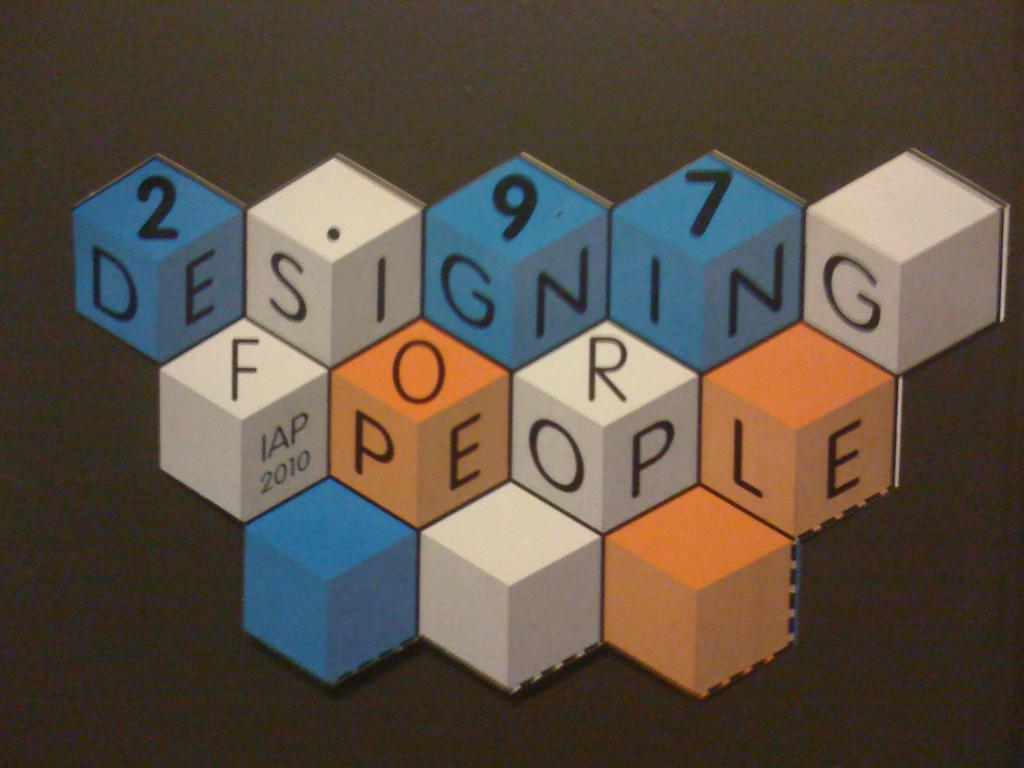<image>
Provide a brief description of the given image. Red, white and orange cubes display the phrase "Designing for the people" on it. 